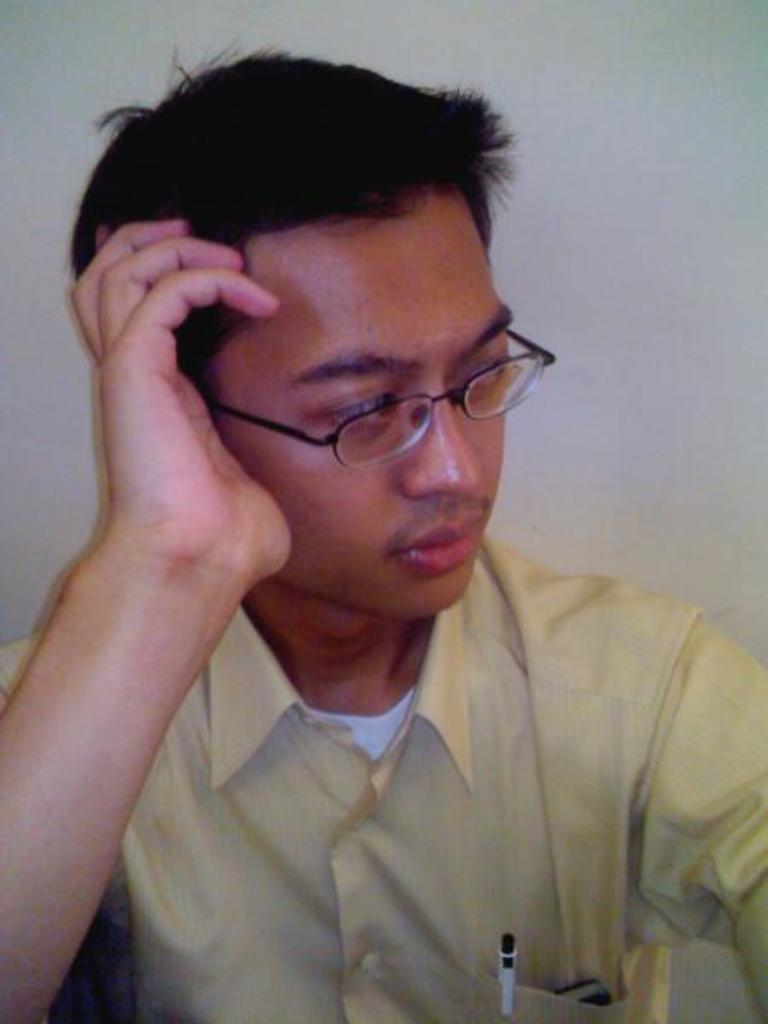What can be seen in the image related to a person? There is a person in the image. What is the person wearing? The person is wearing a yellow shirt. What items does the person have in his pockets? The person has a mobile phone and a pen in his pockets. What accessory is the person wearing on his face? The person is wearing spectacles. What is the person's posture in the image? The person is sitting. How does the person pay for their meal in the image? The image does not show any payment being made, nor is there any indication of a meal being consumed. 